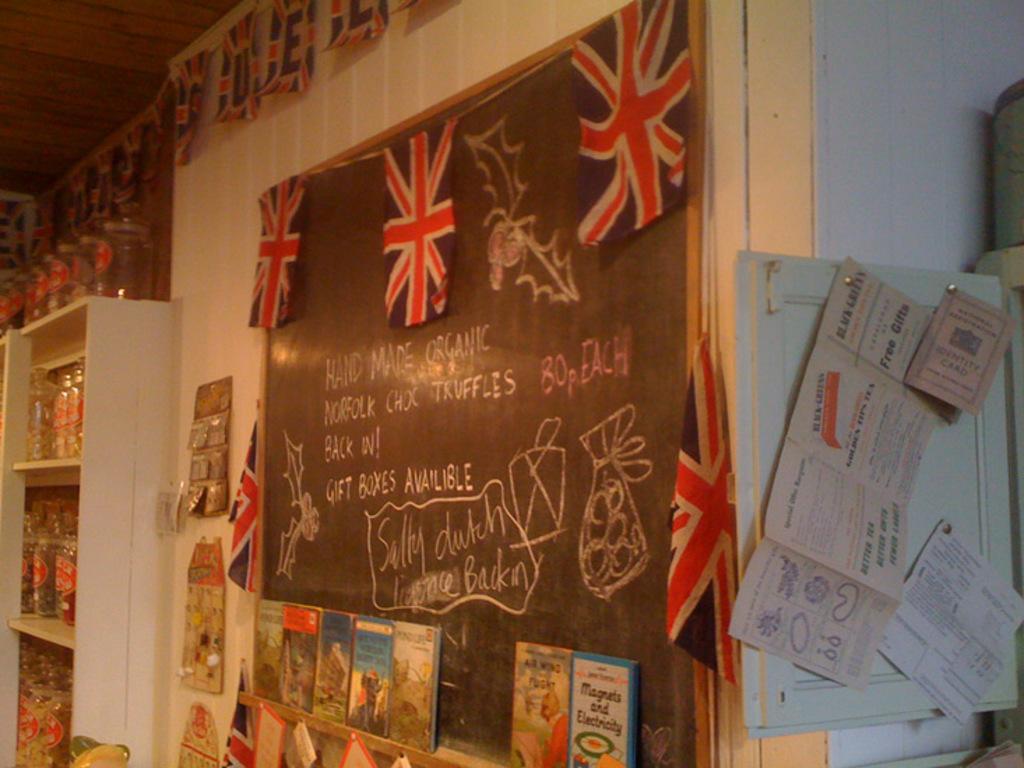What is advertised on the board?
Make the answer very short. Chocolate truffles. 